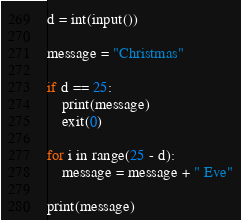Convert code to text. <code><loc_0><loc_0><loc_500><loc_500><_Python_>d = int(input())

message = "Christmas"

if d == 25:
    print(message)
    exit(0)

for i in range(25 - d):
    message = message + " Eve"

print(message)
</code> 